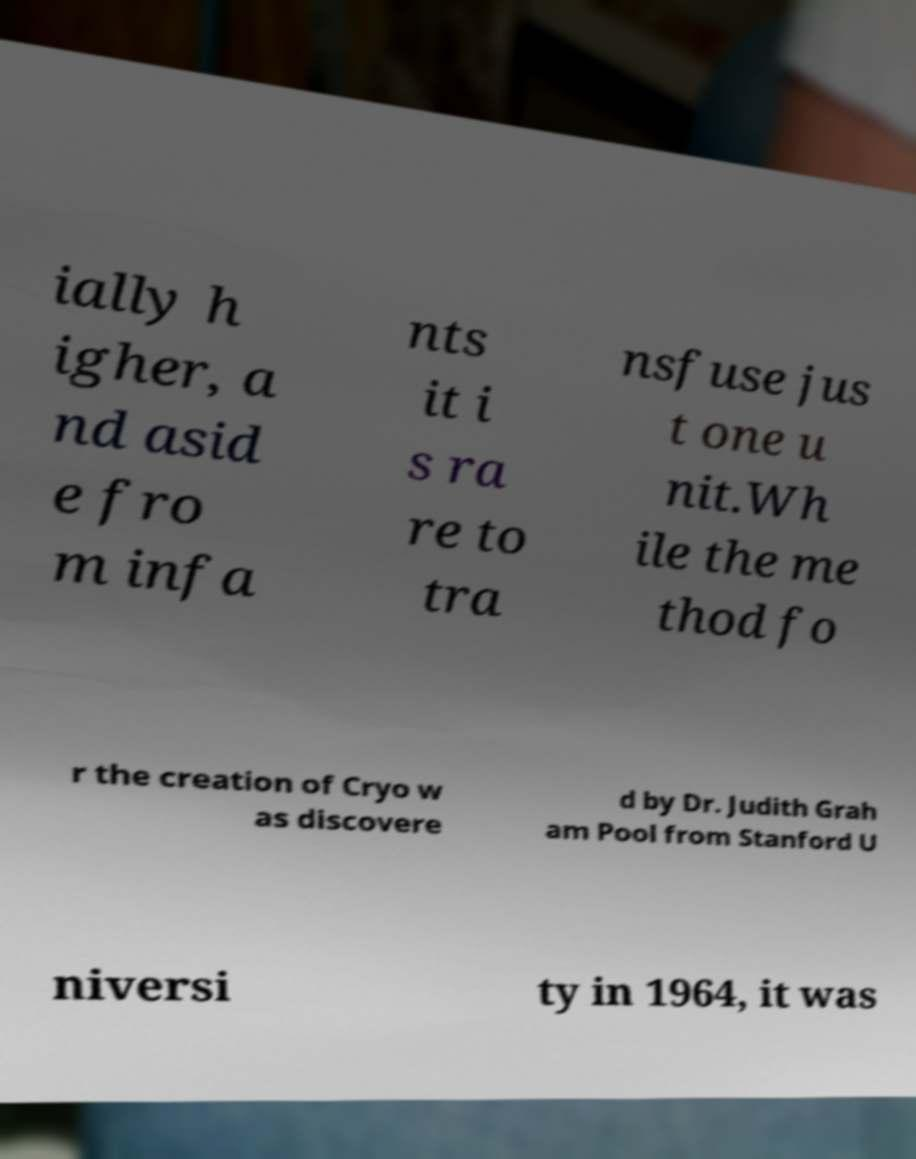Please read and relay the text visible in this image. What does it say? ially h igher, a nd asid e fro m infa nts it i s ra re to tra nsfuse jus t one u nit.Wh ile the me thod fo r the creation of Cryo w as discovere d by Dr. Judith Grah am Pool from Stanford U niversi ty in 1964, it was 